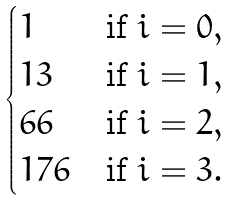<formula> <loc_0><loc_0><loc_500><loc_500>\begin{cases} 1 & \text {if } i = 0 , \\ 1 3 & \text {if } i = 1 , \\ 6 6 & \text {if  } i = 2 , \\ 1 7 6 & \text {if  } i = 3 . \end{cases}</formula> 